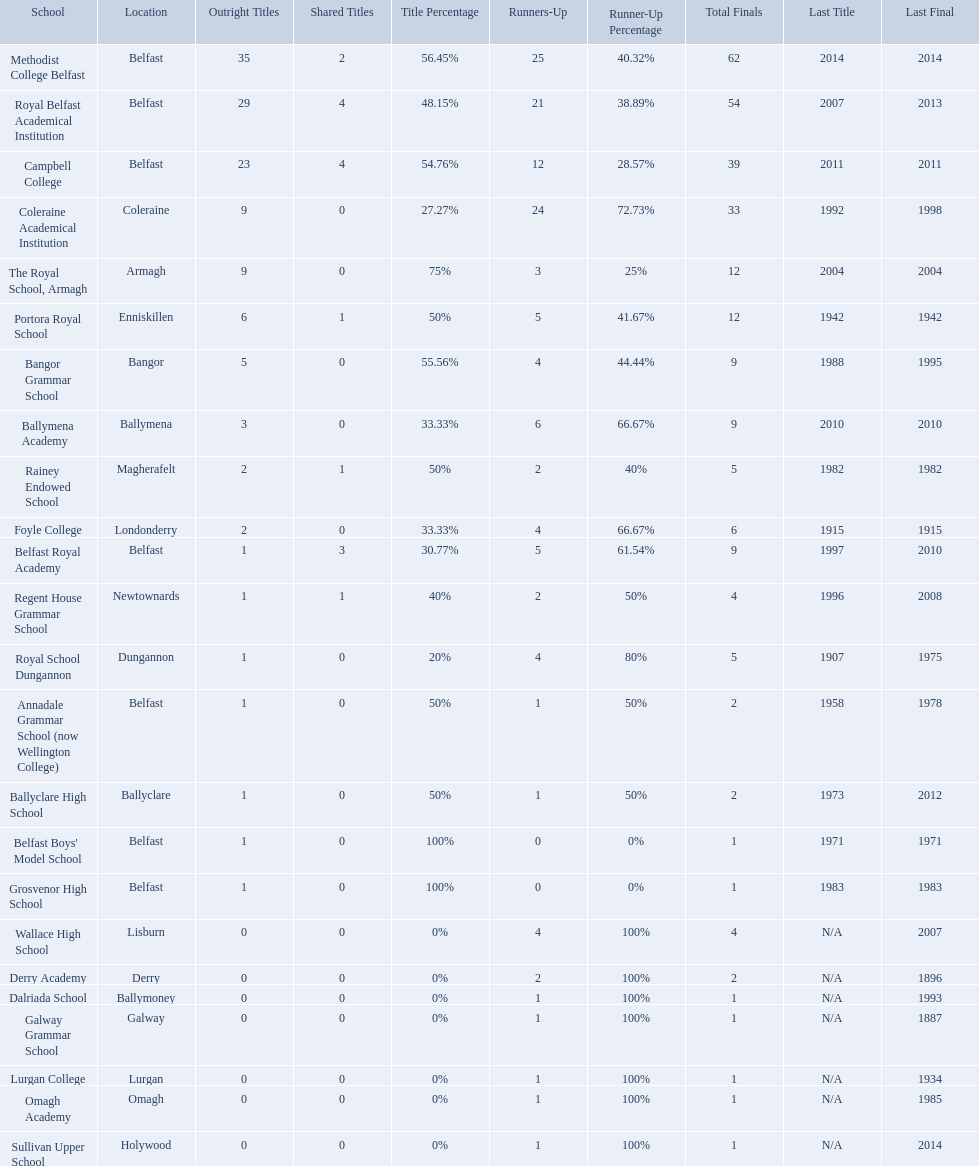How many outright titles does coleraine academical institution have? 9. What other school has this amount of outright titles The Royal School, Armagh. How many schools are there? Methodist College Belfast, Royal Belfast Academical Institution, Campbell College, Coleraine Academical Institution, The Royal School, Armagh, Portora Royal School, Bangor Grammar School, Ballymena Academy, Rainey Endowed School, Foyle College, Belfast Royal Academy, Regent House Grammar School, Royal School Dungannon, Annadale Grammar School (now Wellington College), Ballyclare High School, Belfast Boys' Model School, Grosvenor High School, Wallace High School, Derry Academy, Dalriada School, Galway Grammar School, Lurgan College, Omagh Academy, Sullivan Upper School. How many outright titles does the coleraine academical institution have? 9. What other school has the same number of outright titles? The Royal School, Armagh. Which schools are listed? Methodist College Belfast, Royal Belfast Academical Institution, Campbell College, Coleraine Academical Institution, The Royal School, Armagh, Portora Royal School, Bangor Grammar School, Ballymena Academy, Rainey Endowed School, Foyle College, Belfast Royal Academy, Regent House Grammar School, Royal School Dungannon, Annadale Grammar School (now Wellington College), Ballyclare High School, Belfast Boys' Model School, Grosvenor High School, Wallace High School, Derry Academy, Dalriada School, Galway Grammar School, Lurgan College, Omagh Academy, Sullivan Upper School. When did campbell college win the title last? 2011. When did regent house grammar school win the title last? 1996. Of those two who had the most recent title win? Campbell College. What is the most recent win of campbell college? 2011. What is the most recent win of regent house grammar school? 1996. Which date is more recent? 2011. What is the name of the school with this date? Campbell College. 